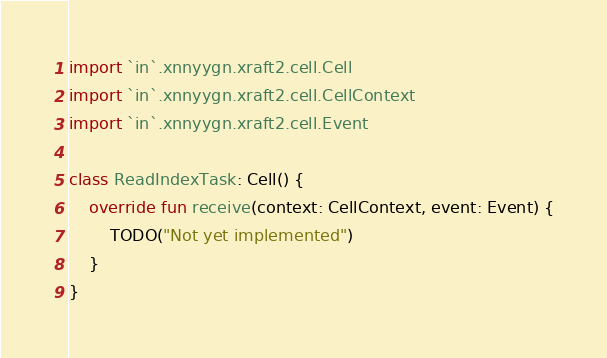<code> <loc_0><loc_0><loc_500><loc_500><_Kotlin_>
import `in`.xnnyygn.xraft2.cell.Cell
import `in`.xnnyygn.xraft2.cell.CellContext
import `in`.xnnyygn.xraft2.cell.Event

class ReadIndexTask: Cell() {
    override fun receive(context: CellContext, event: Event) {
        TODO("Not yet implemented")
    }
}</code> 